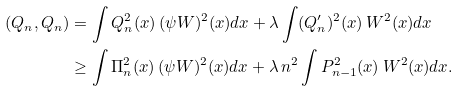Convert formula to latex. <formula><loc_0><loc_0><loc_500><loc_500>( Q _ { n } , Q _ { n } ) & = \int Q _ { n } ^ { 2 } ( x ) \, ( \psi W ) ^ { 2 } ( x ) d x + \lambda \int ( Q _ { n } ^ { \prime } ) ^ { 2 } ( x ) \, W ^ { 2 } ( x ) d x \\ & \geq \int \Pi _ { n } ^ { 2 } ( x ) \, ( \psi W ) ^ { 2 } ( x ) d x + \lambda \, n ^ { 2 } \int P _ { n - 1 } ^ { 2 } ( x ) \, W ^ { 2 } ( x ) d x .</formula> 